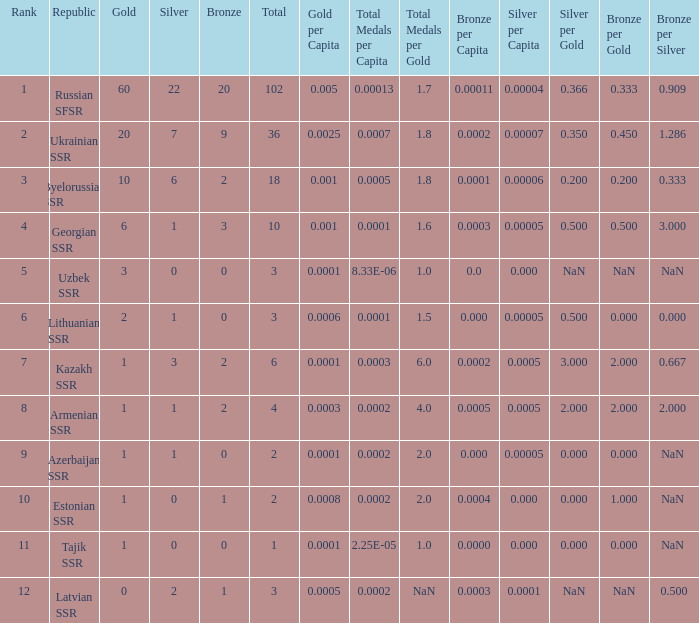What is the highest number of bronzes for teams ranked number 7 with more than 0 silver? 2.0. 